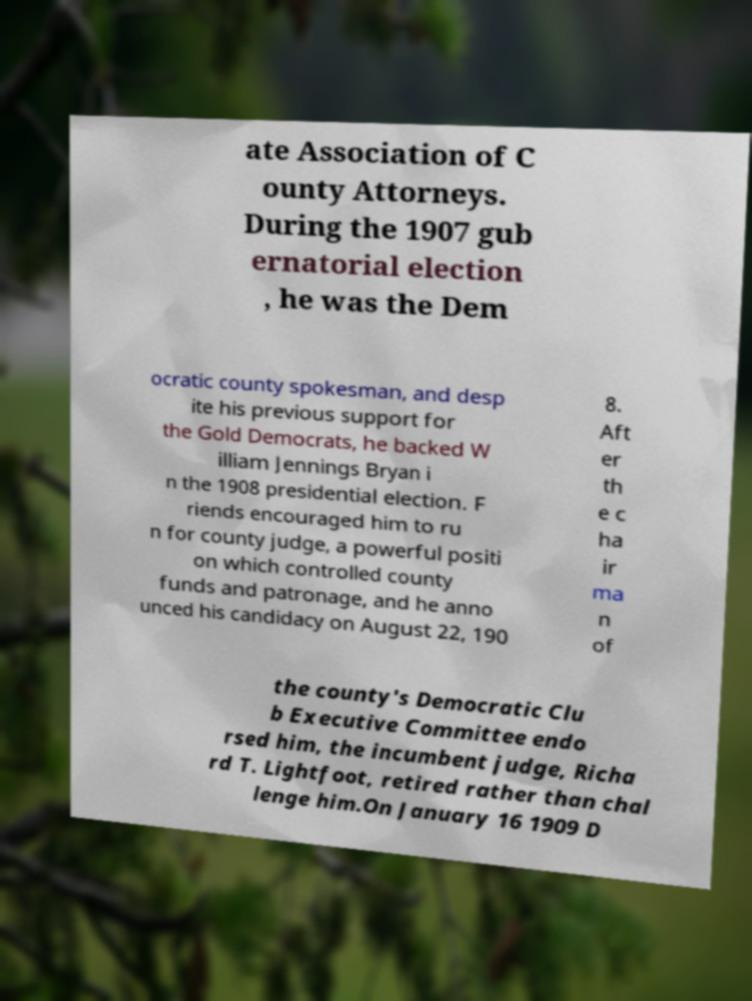For documentation purposes, I need the text within this image transcribed. Could you provide that? ate Association of C ounty Attorneys. During the 1907 gub ernatorial election , he was the Dem ocratic county spokesman, and desp ite his previous support for the Gold Democrats, he backed W illiam Jennings Bryan i n the 1908 presidential election. F riends encouraged him to ru n for county judge, a powerful positi on which controlled county funds and patronage, and he anno unced his candidacy on August 22, 190 8. Aft er th e c ha ir ma n of the county's Democratic Clu b Executive Committee endo rsed him, the incumbent judge, Richa rd T. Lightfoot, retired rather than chal lenge him.On January 16 1909 D 